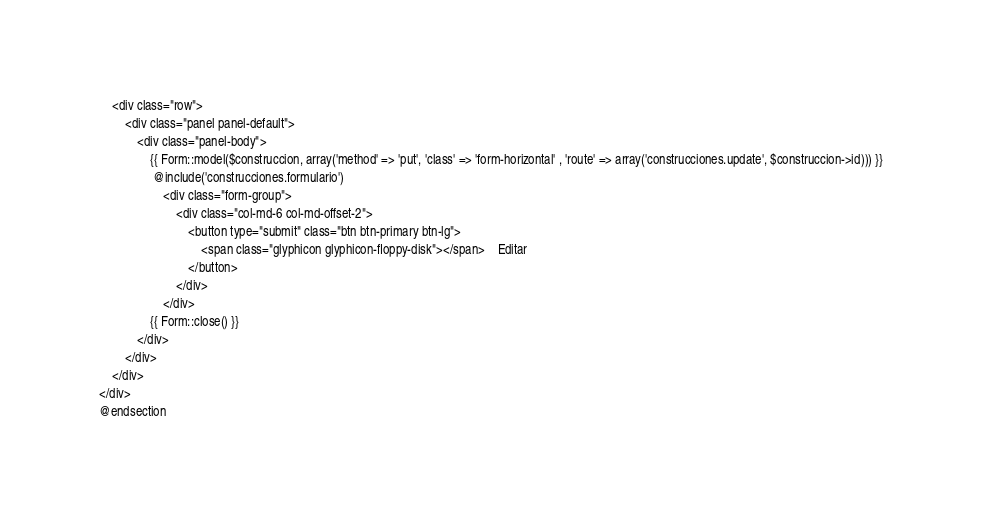<code> <loc_0><loc_0><loc_500><loc_500><_PHP_>    <div class="row">
        <div class="panel panel-default">
            <div class="panel-body">
                {{ Form::model($construccion, array('method' => 'put', 'class' => 'form-horizontal' , 'route' => array('construcciones.update', $construccion->id))) }}
                 @include('construcciones.formulario')
                    <div class="form-group">
                        <div class="col-md-6 col-md-offset-2">
                            <button type="submit" class="btn btn-primary btn-lg">
                                <span class="glyphicon glyphicon-floppy-disk"></span>    Editar
                            </button>
                        </div>
                    </div>
                {{ Form::close() }}
            </div>
        </div>
    </div>
</div>
@endsection
</code> 